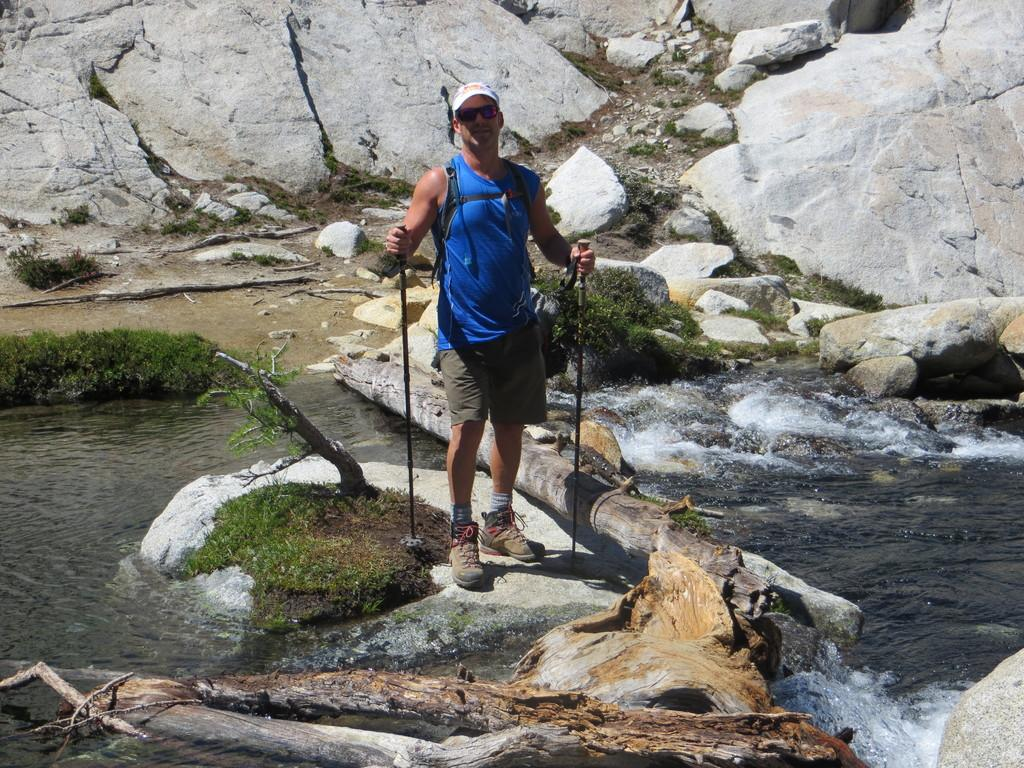Who is present in the image? There is a person in the image. What is the person holding in the image? The person is holding trekking poles. Where is the person standing in the image? The person is standing on a rock. What can be seen in the background of the image? There is water, rocks, and grass visible in the background of the image. How fast is the person driving in the image? There is no vehicle or driving activity present in the image; the person is standing on a rock with trekking poles. 